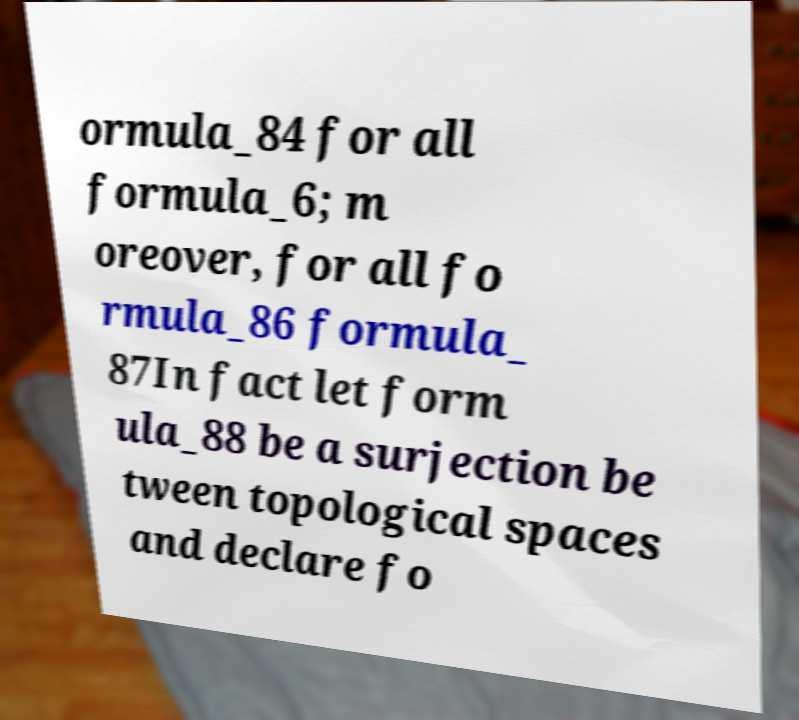Can you accurately transcribe the text from the provided image for me? ormula_84 for all formula_6; m oreover, for all fo rmula_86 formula_ 87In fact let form ula_88 be a surjection be tween topological spaces and declare fo 